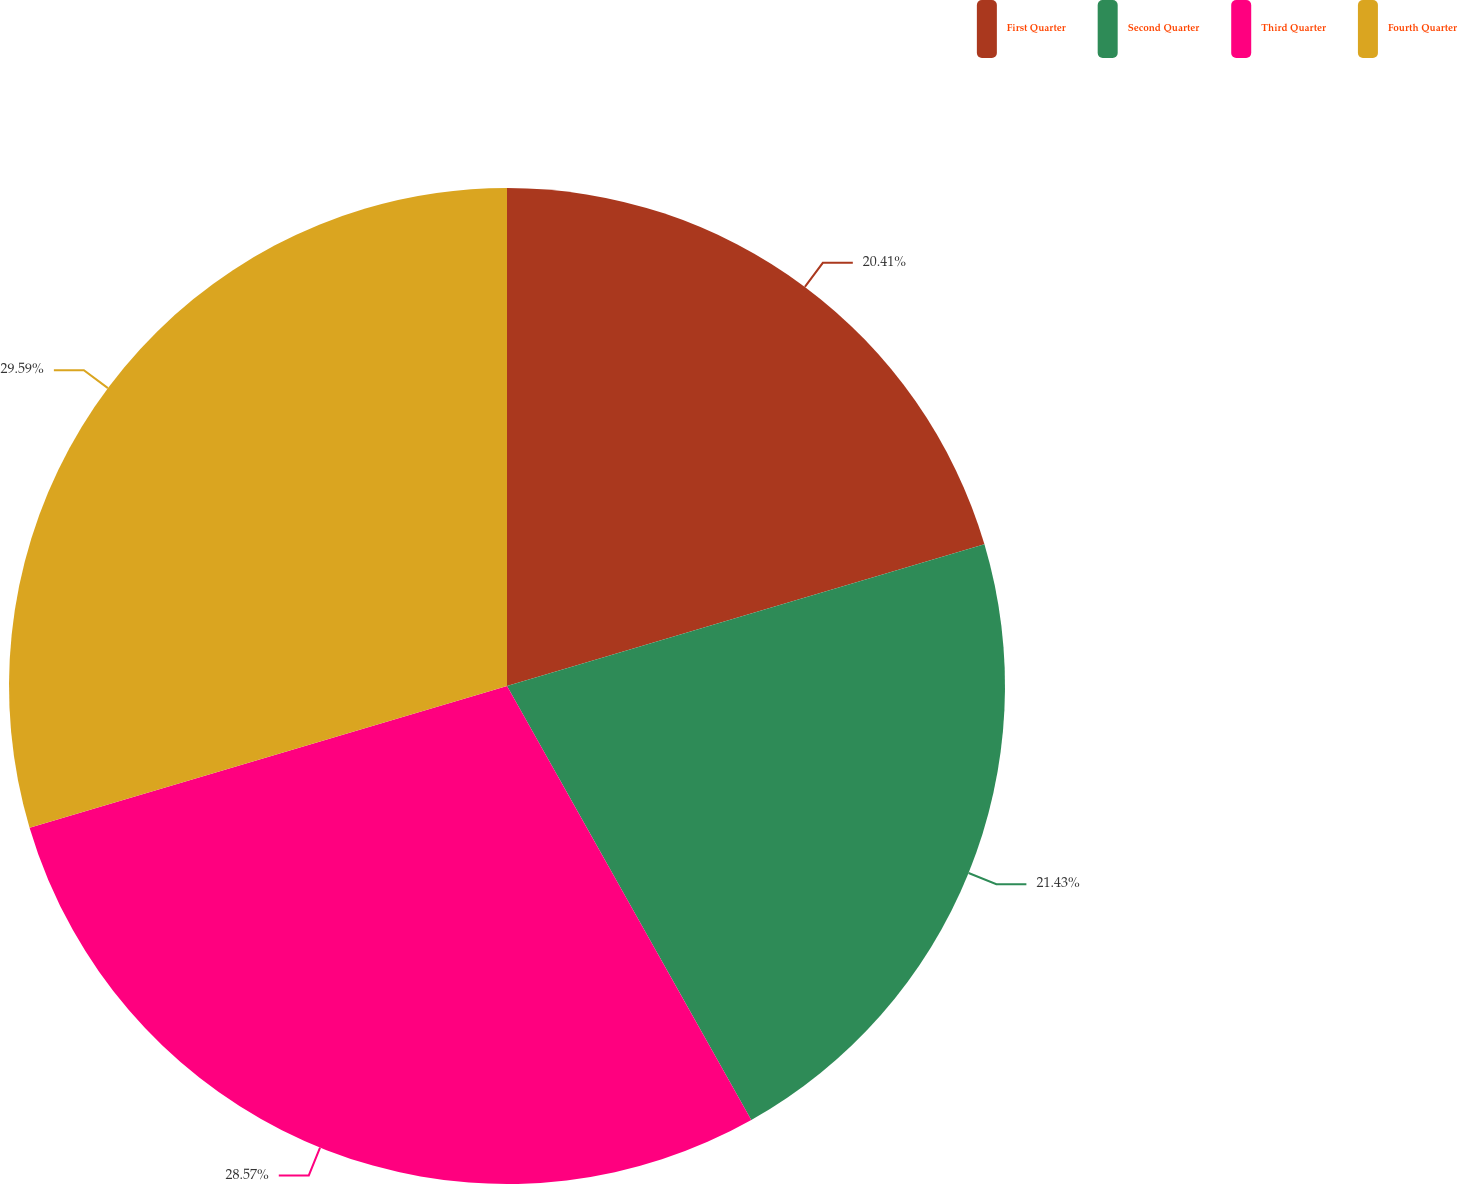Convert chart to OTSL. <chart><loc_0><loc_0><loc_500><loc_500><pie_chart><fcel>First Quarter<fcel>Second Quarter<fcel>Third Quarter<fcel>Fourth Quarter<nl><fcel>20.41%<fcel>21.43%<fcel>28.57%<fcel>29.59%<nl></chart> 